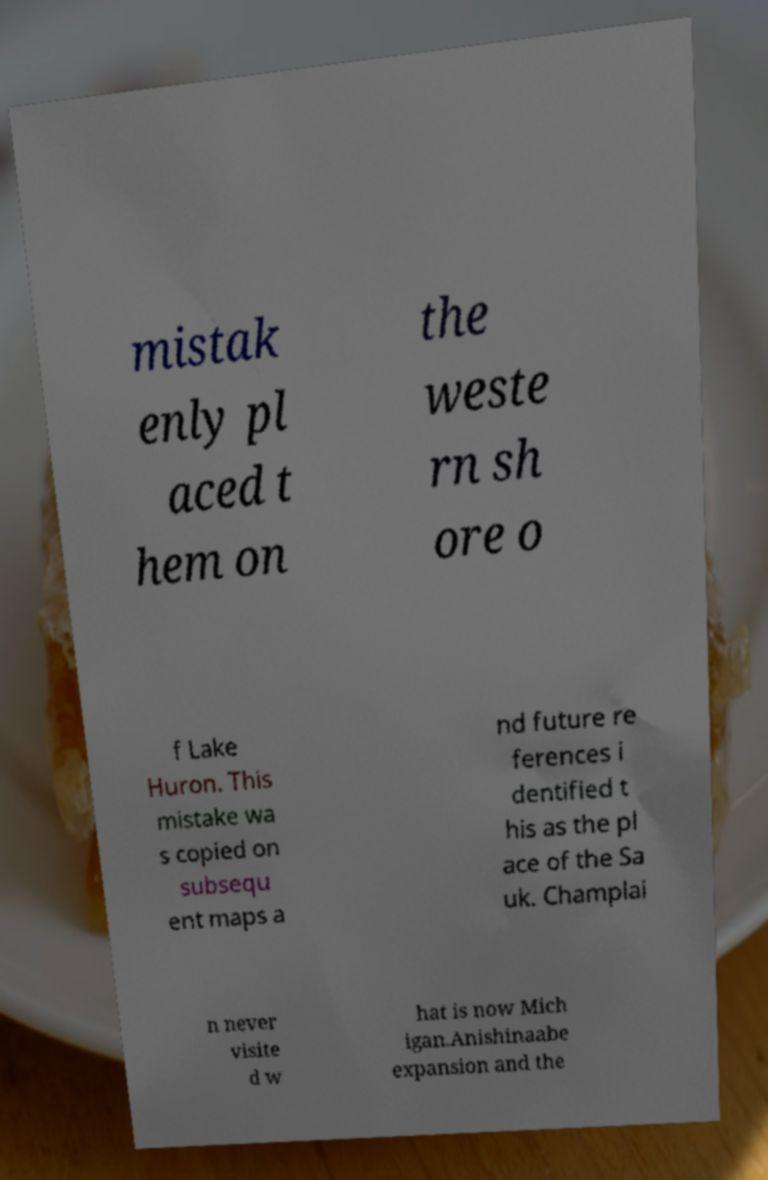What messages or text are displayed in this image? I need them in a readable, typed format. mistak enly pl aced t hem on the weste rn sh ore o f Lake Huron. This mistake wa s copied on subsequ ent maps a nd future re ferences i dentified t his as the pl ace of the Sa uk. Champlai n never visite d w hat is now Mich igan.Anishinaabe expansion and the 